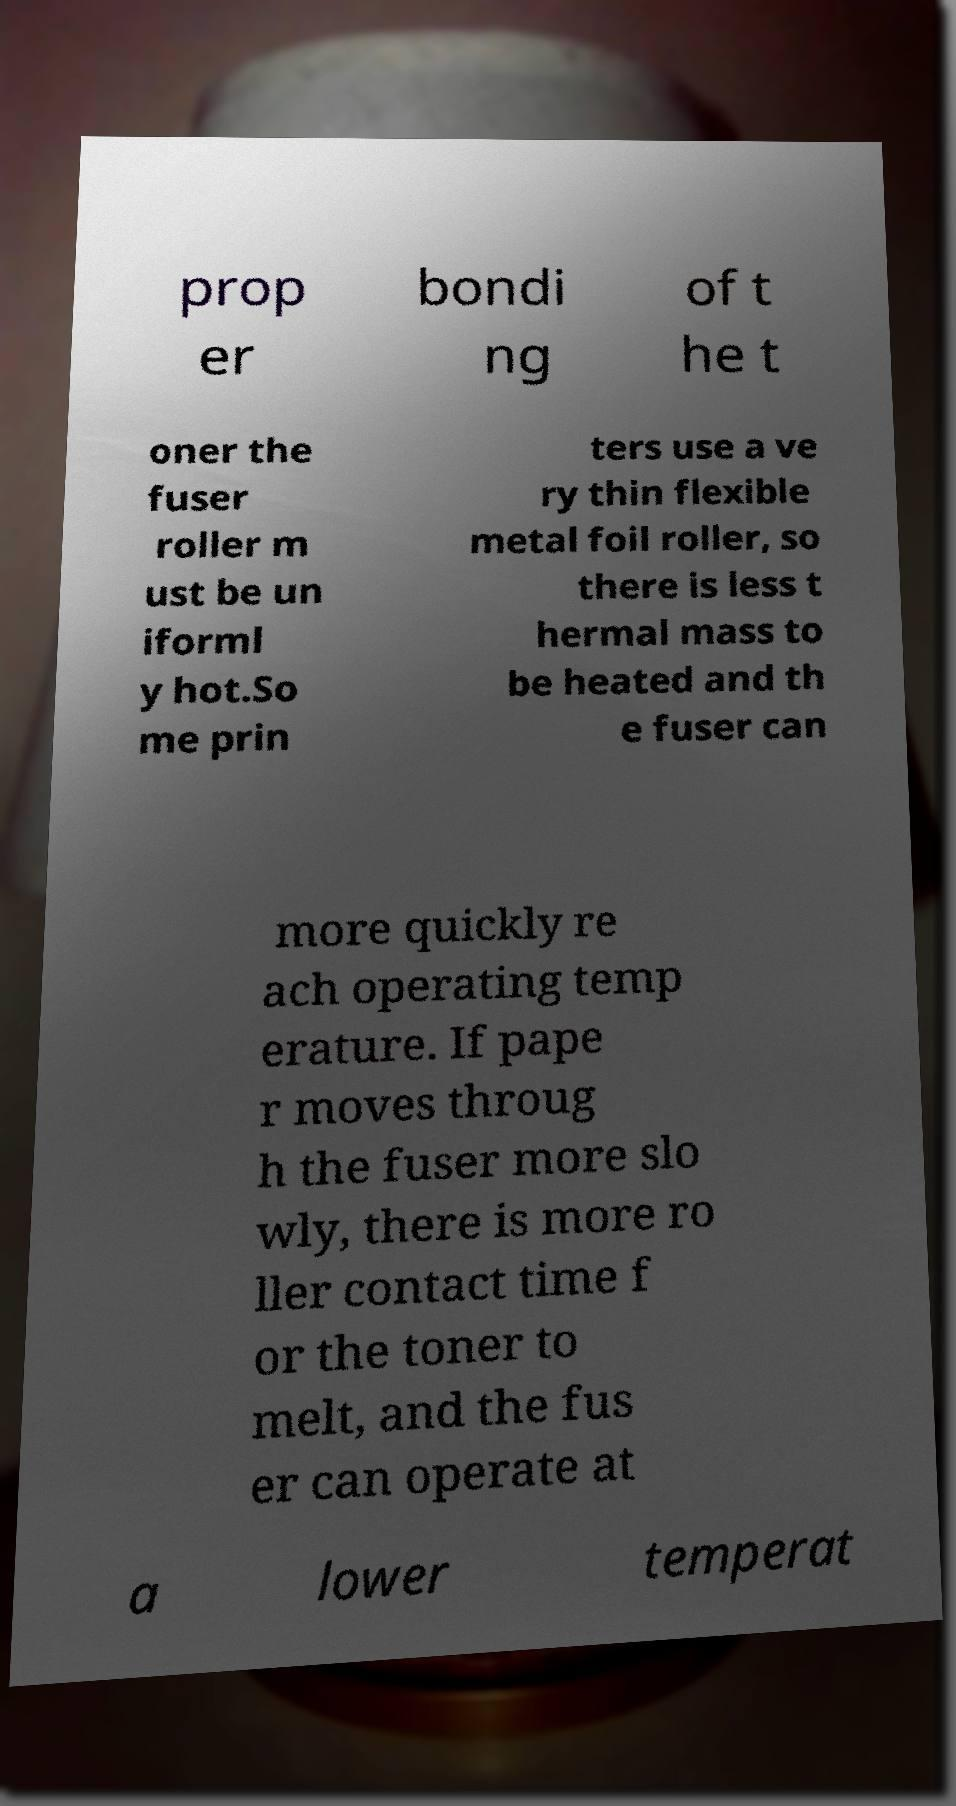Can you accurately transcribe the text from the provided image for me? prop er bondi ng of t he t oner the fuser roller m ust be un iforml y hot.So me prin ters use a ve ry thin flexible metal foil roller, so there is less t hermal mass to be heated and th e fuser can more quickly re ach operating temp erature. If pape r moves throug h the fuser more slo wly, there is more ro ller contact time f or the toner to melt, and the fus er can operate at a lower temperat 